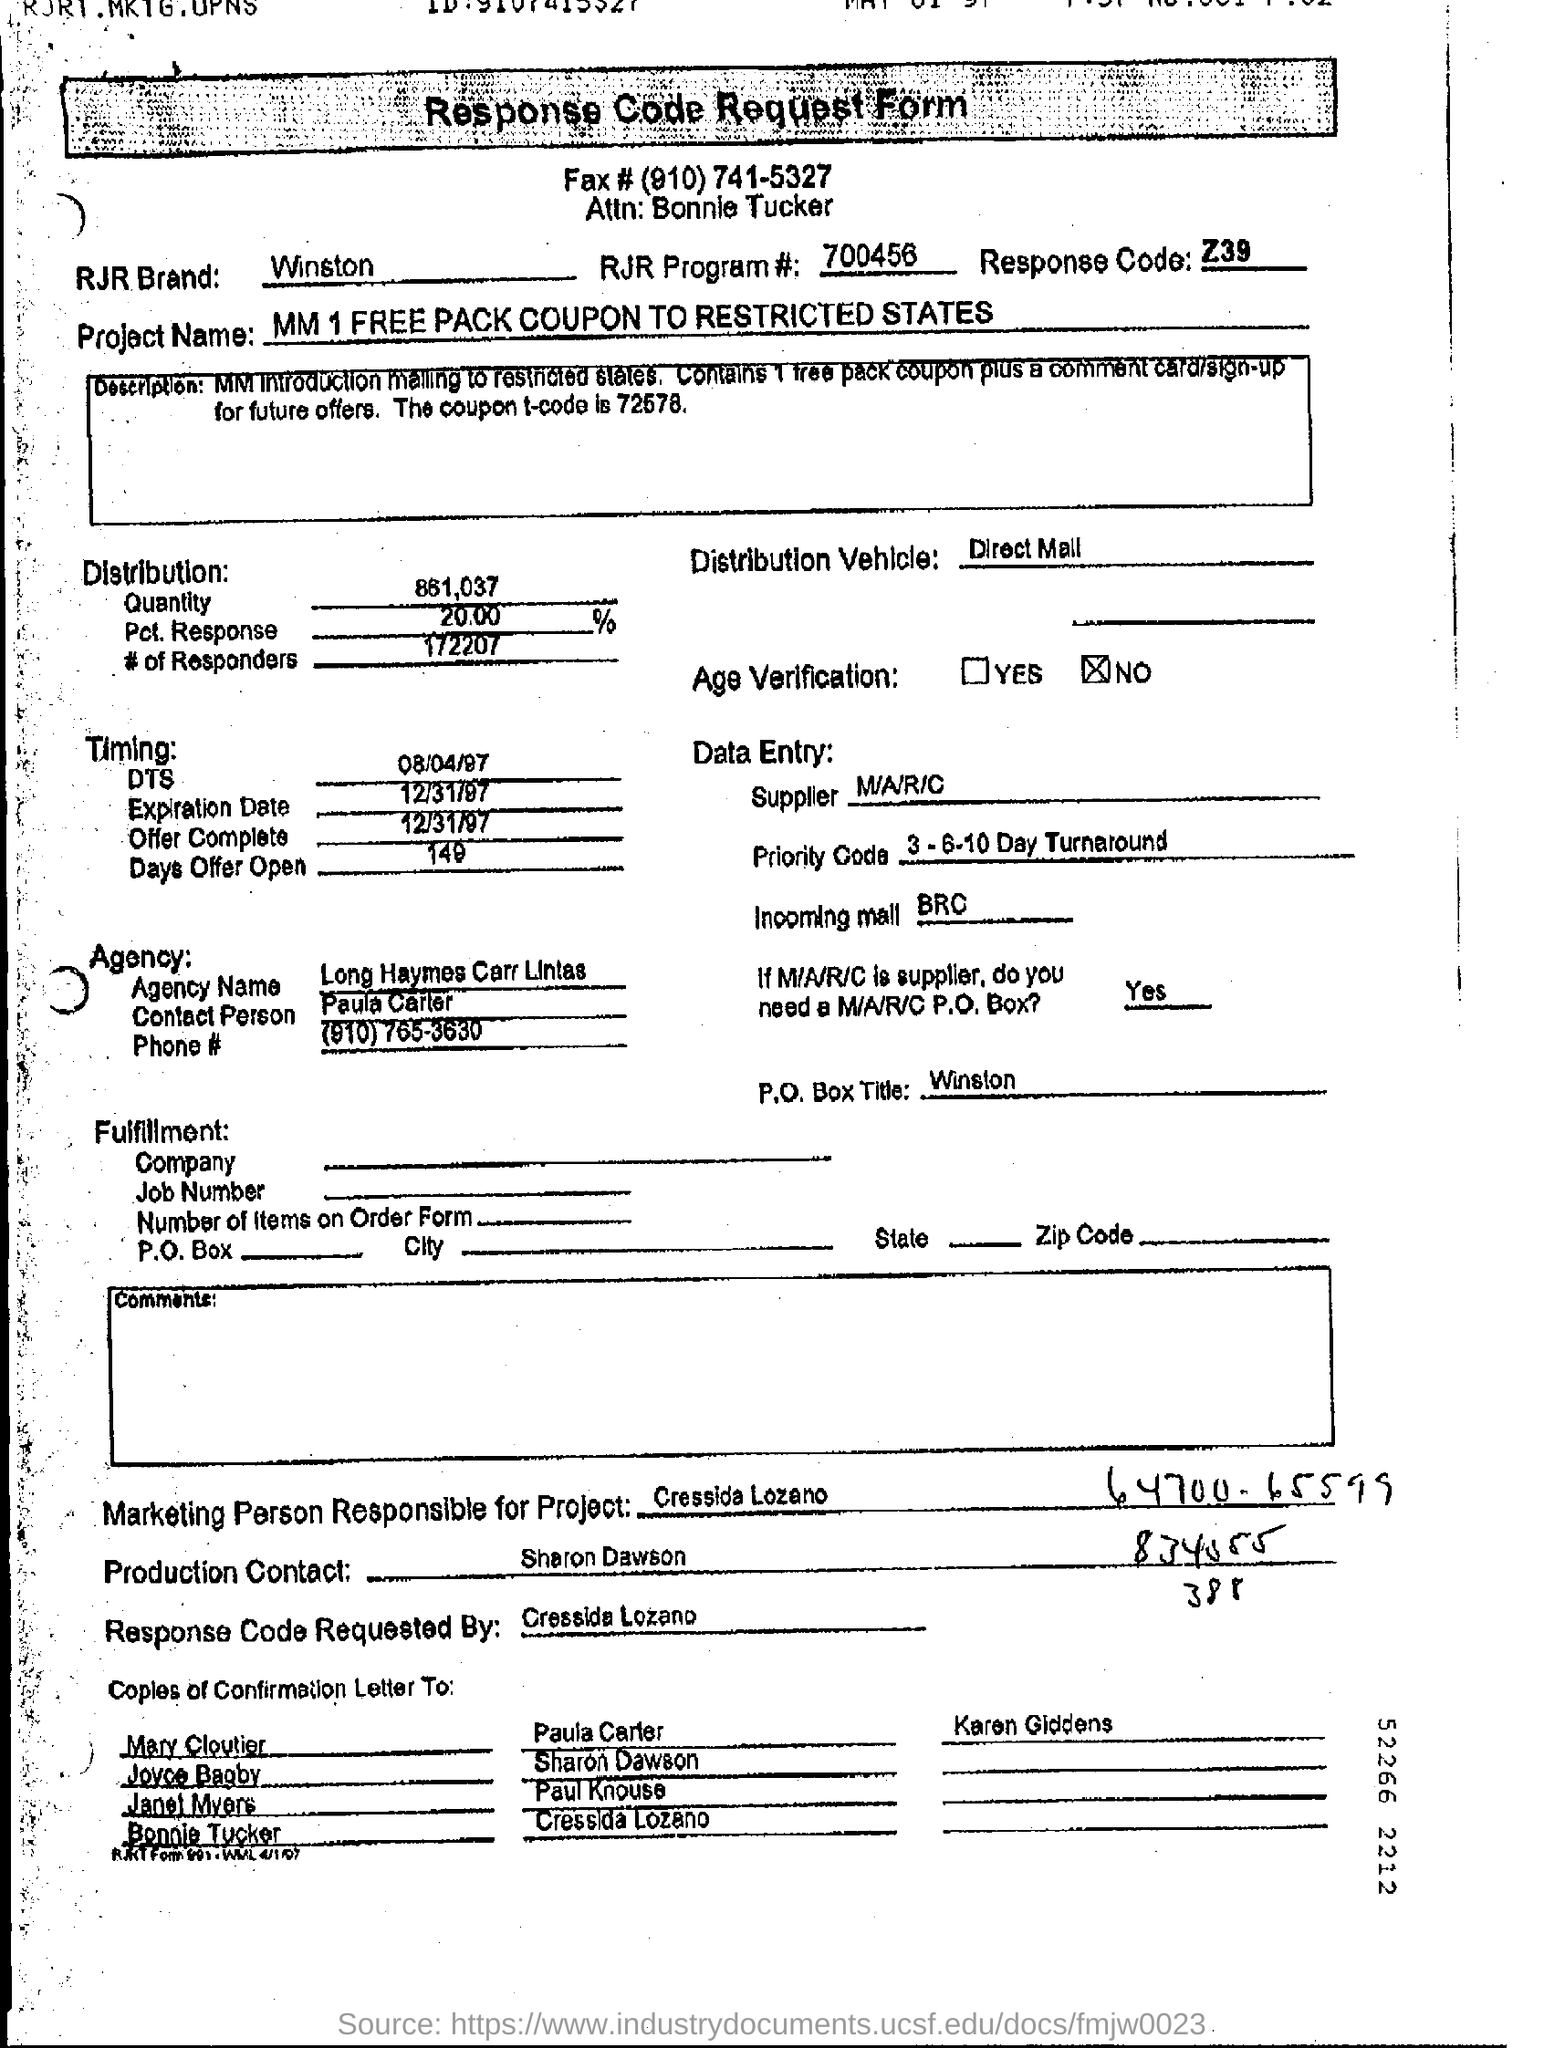What is the RJR Brand?
Offer a very short reply. Winston. What is the RJR Program # number?
Provide a succinct answer. 700456. What is the Response Code?
Your answer should be compact. Z39. 